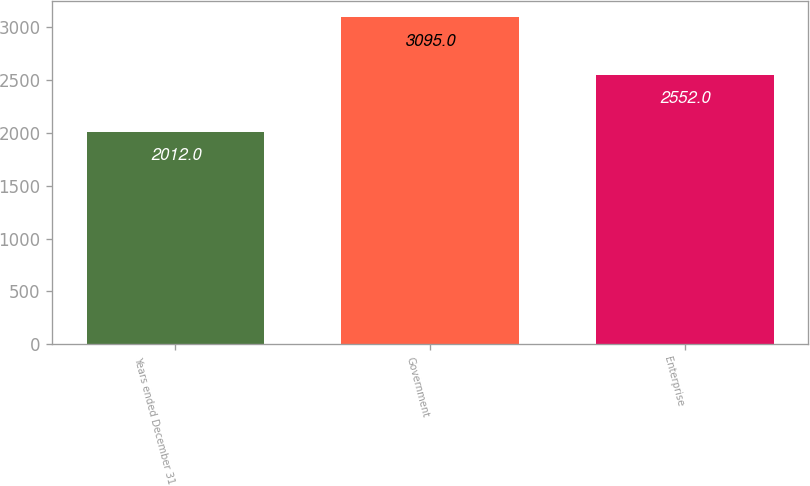Convert chart. <chart><loc_0><loc_0><loc_500><loc_500><bar_chart><fcel>Years ended December 31<fcel>Government<fcel>Enterprise<nl><fcel>2012<fcel>3095<fcel>2552<nl></chart> 